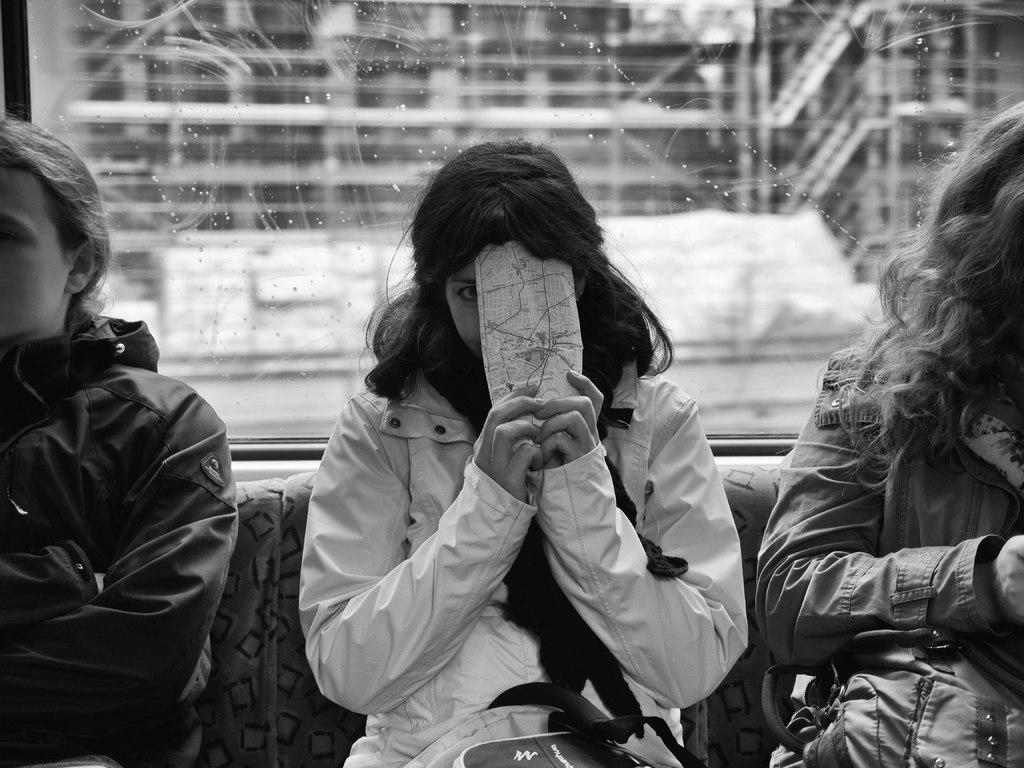What are the people in the image doing? The people in the image are sitting. What is the woman holding in the image? The woman is holding a paper in the image. Can you describe any objects visible in the background of the image? There is a glass visible in the background of the image. What type of roll can be seen in the image? There is no roll present in the image. Is this image taken at a school? The provided facts do not mention anything about the location being a school, so we cannot determine that from the image. 